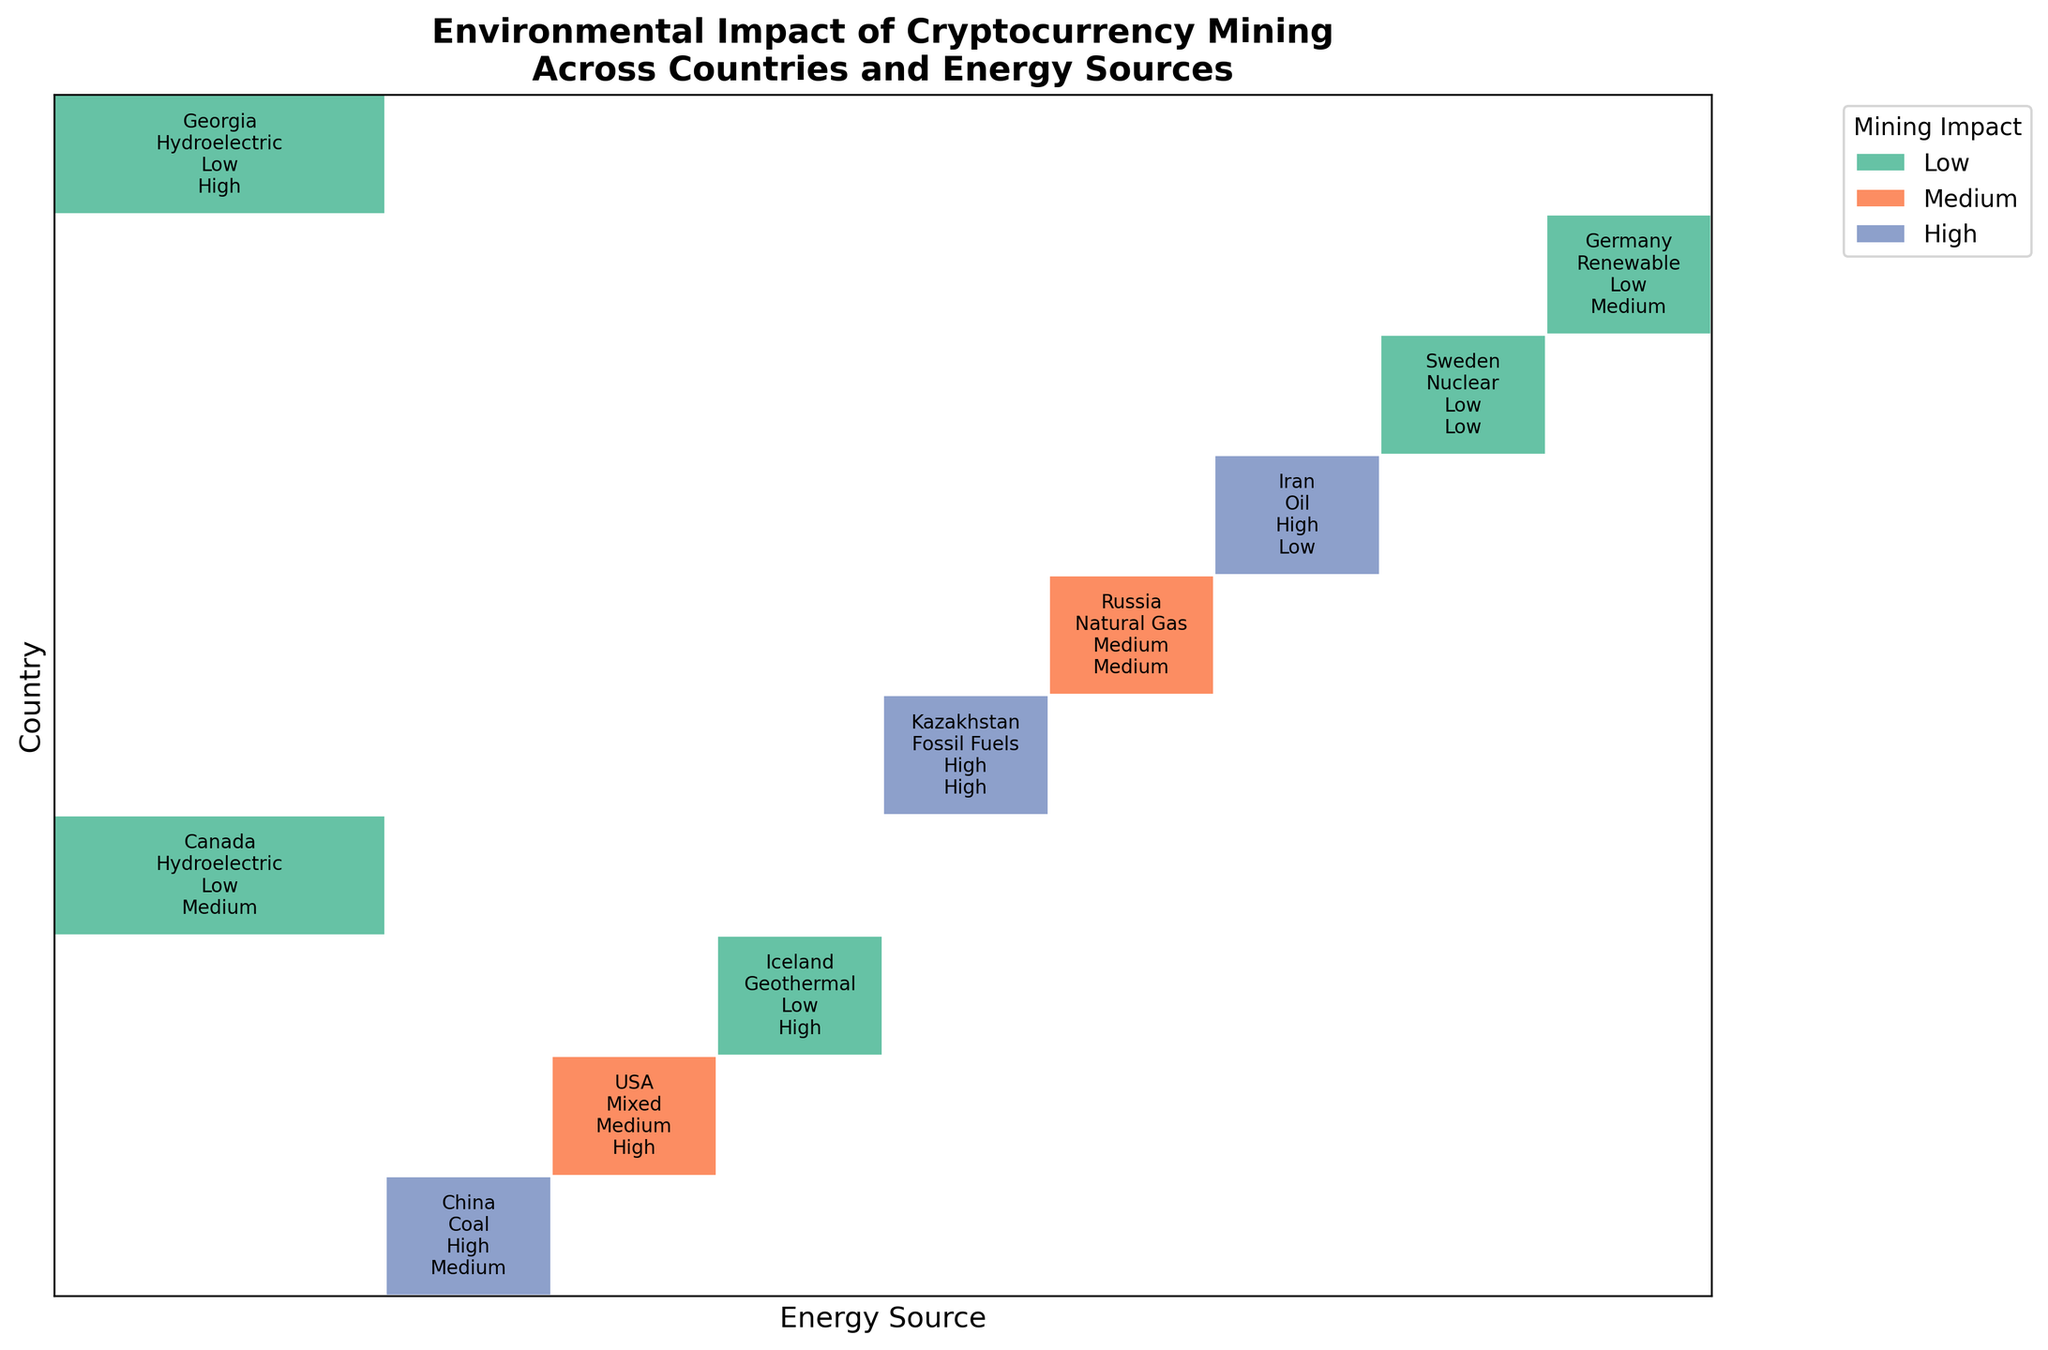Which country has the highest environmental impact due to cryptocurrency mining? To determine which country has the highest environmental impact, look for the largest "High" (blue) rectangle with the country's name.
Answer: China Which mining impact level is most commonly associated with renewable energy sources in the figure? Check the rectangles corresponding to renewable energy sources and note the mining impact levels (colors) associated with them. The majority color will indicate the most common mining impact level.
Answer: Low What is the adoption level of cryptocurrency mining in Iceland, and what is its environmental impact? Locate Iceland and check the associated adoption level and mining impact written in the rectangle.
Answer: High, Low Compare the mining impacts of the USA and Iran. Which one is higher? Find the rectangles for the USA and Iran, and compare the mining impact levels (indicated by colors) between the two countries.
Answer: Iran Among the countries shown, which one uses geothermal energy for cryptocurrency mining, and what is its environmental impact? Identify the country associated with geothermal energy by looking at the rectangular label and note the mining impact level written beside it.
Answer: Iceland, Low Which country has the least environmental impact along with a high level of cryptocurrency adoption? Examine the rectangles for each country, find the ones with a "Low" environmental impact and check their adoption levels.
Answer: Iceland Between Kazakhstan and Germany, which country has a higher adoption level of cryptocurrency mining, and what are their respective environmental impacts? Compare the adoption levels (text in the rectangles) of Kazakhstan and Germany and their corresponding mining impacts.
Answer: Kazakhstan, High; Germany, Low How does the adoption level of Norway compare to Canada regarding cryptocurrency mining? Check the adoption levels of Norway and Canada by reading the text in the rectangles. Note that Norway is not listed in the provided data, thus Canada is only considered.
Answer: Canada only shown What energy sources are used by countries with a medium mining impact level? Identify the countries with a medium mining impact level, then note the energy sources listed on their respective rectangles.
Answer: Mixed, Natural Gas Which country uses hydroelectric energy for cryptocurrency mining and has a high level of adoption? Find the rectangle labeled with hydroelectric energy and check for the corresponding country's name with a high adoption level.
Answer: Georgia 